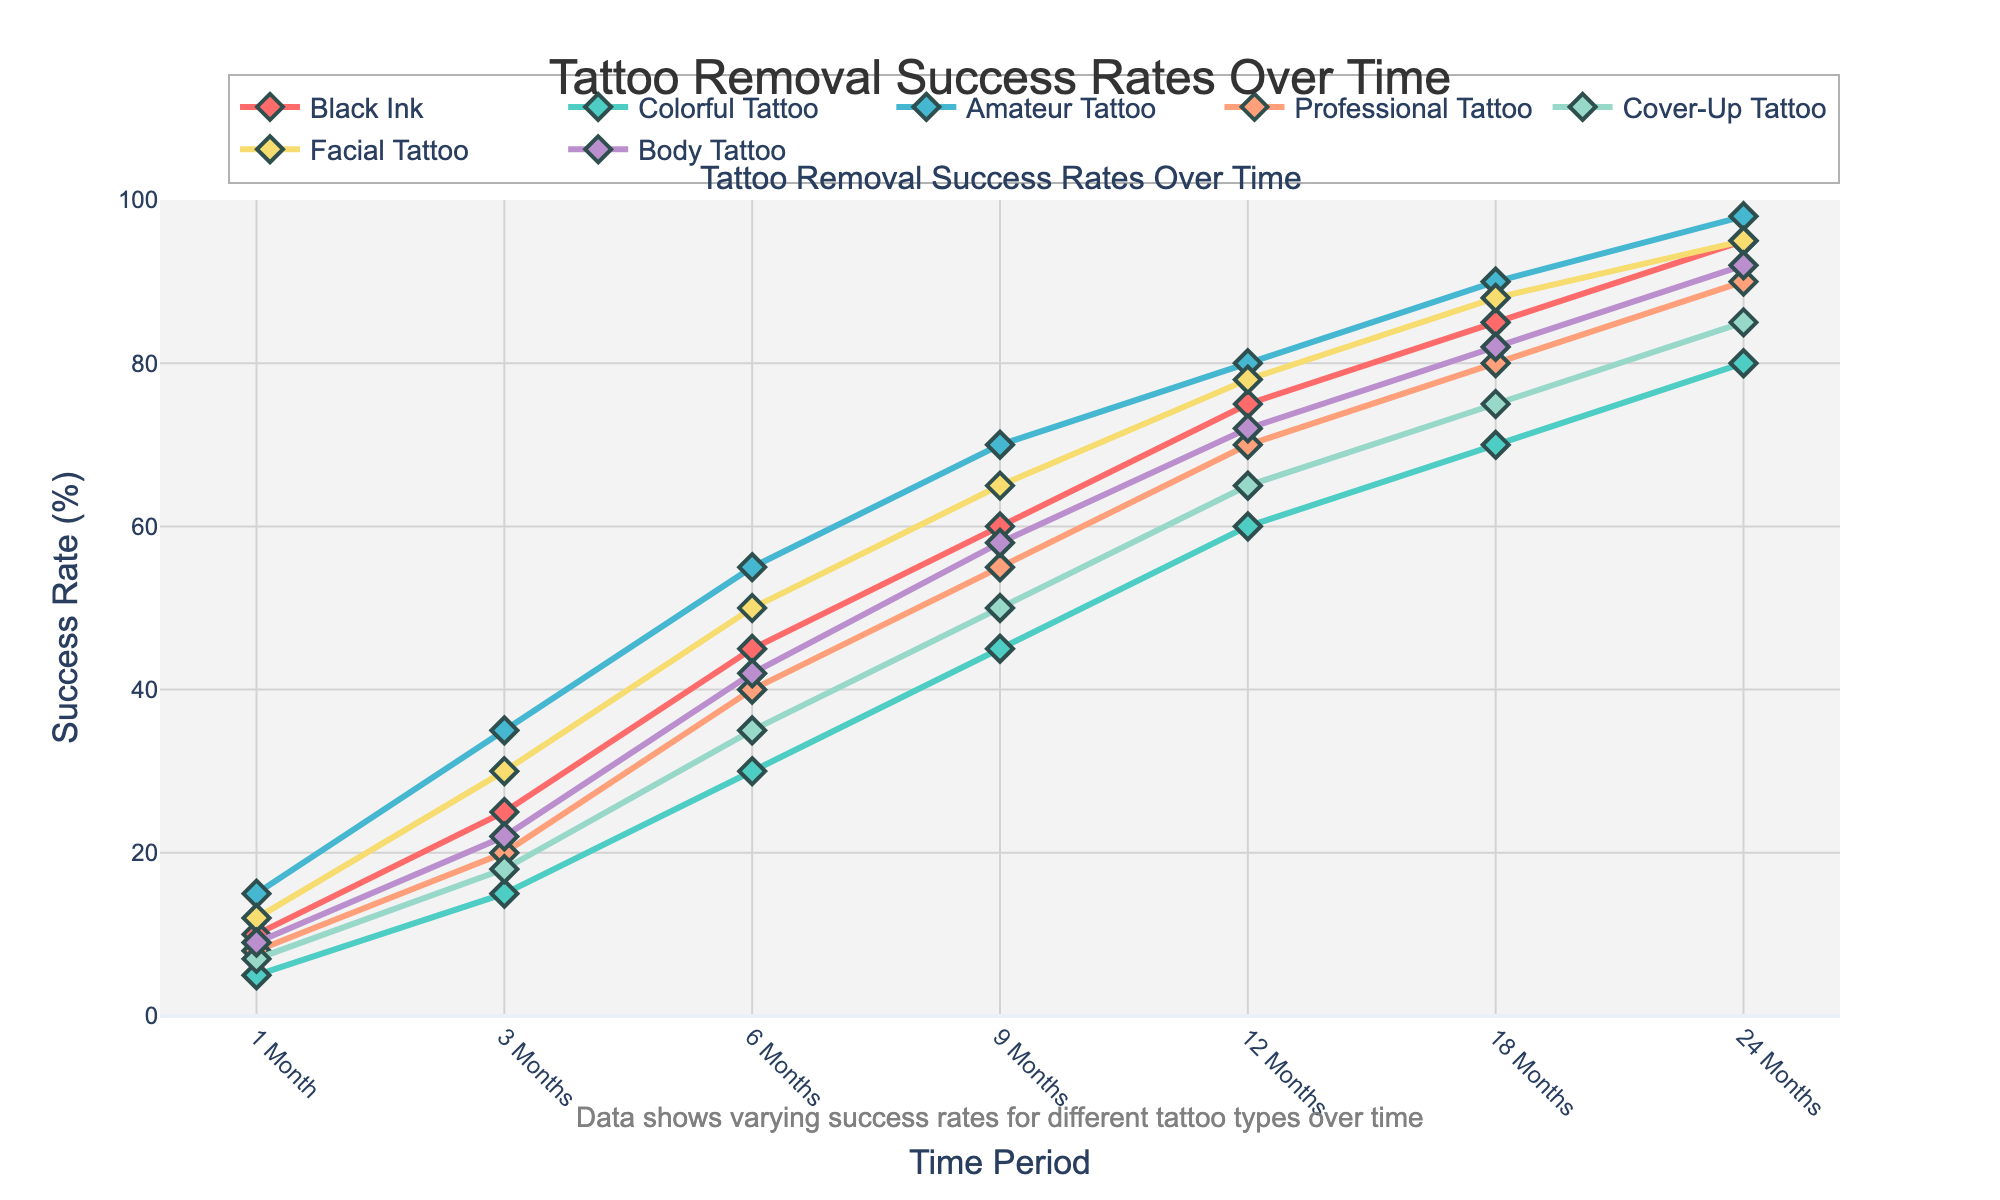What's the success rate for Black Ink tattoos at 12 months? To find the success rate for Black Ink tattoos at 12 months, look at the Black Ink line on the chart and locate the value corresponding to the 12-month mark.
Answer: 75% Which tattoo type shows the highest success rate at 24 months? To determine the highest success rate at 24 months, compare the end values of all the lines on the chart. The line for Amateur Tattoo reaches the highest point at 24 months.
Answer: Amateur Tattoo How does the success rate for Professional Tattoos at 6 months compare to that for Colorful Tattoos at the same time point? At 6 months, find the values for Professional Tattoos and Colorful Tattoos on the chart. Professional Tattoos have a value of 40%, while Colorful Tattoos have a value of 30%. Hence, Professional Tattoos have a 10% higher success rate at 6 months.
Answer: Professional Tattoos have a 10% higher success rate What's the average success rate for Facial Tattoos across all time points shown? Sum the success rates for Facial Tattoos at each time point and divide by the number of time points: (12 + 30 + 50 + 65 + 78 + 88 + 95) / 7. This equals 60.4286, rounding to 60.43%.
Answer: 60.43% Which tattoo type experiences the steepest increase in success rate from 1 month to 3 months? To find the steepest increase from 1 to 3 months, look at the difference between these time points for each tattoo type. The largest increase is for Amateur Tattoos, going from 15% to 35%, a 20% increase.
Answer: Amateur Tattoo By how much does the success rate for Cover-Up Tattoos increase from 9 months to 18 months? Calculate the difference in success rates between 9 months and 18 months for Cover-Up Tattoos: 75% - 50% = 25%.
Answer: 25% Are Body Tattoos more successful than Cover-Up Tattoos at 12 months? Compare the success rates of Body Tattoos and Cover-Up Tattoos at the 12-month mark. Body Tattoos have a success rate of 72%, while Cover-Up Tattoos have a success rate of 65%. Thus, Body Tattoos are more successful.
Answer: Yes Which tattoo type has the highest initial success rate at 1 month? To find the tattoo type with the highest initial success rate at 1 month, look at the values for all tattoo types at the 1-month mark. Amateur Tattoos have the highest value at 15%.
Answer: Amateur Tattoo What's the success rate difference between Facial and Body Tattoos at 18 months? To find the success rate difference at 18 months, subtract the success rate for Body Tattoos from the success rate for Facial Tattoos: 88% - 82% = 6%.
Answer: 6% If the success rate for Black Ink tattoos grows linearly from 18 months to 24 months, what would be the monthly increase rate? First, find the difference between the 18-month and 24-month success rates for Black Ink tattoos: 95% - 85% = 10%. Then, divide by the number of months: 10% / 6 months = 1.67% per month.
Answer: 1.67% per month 